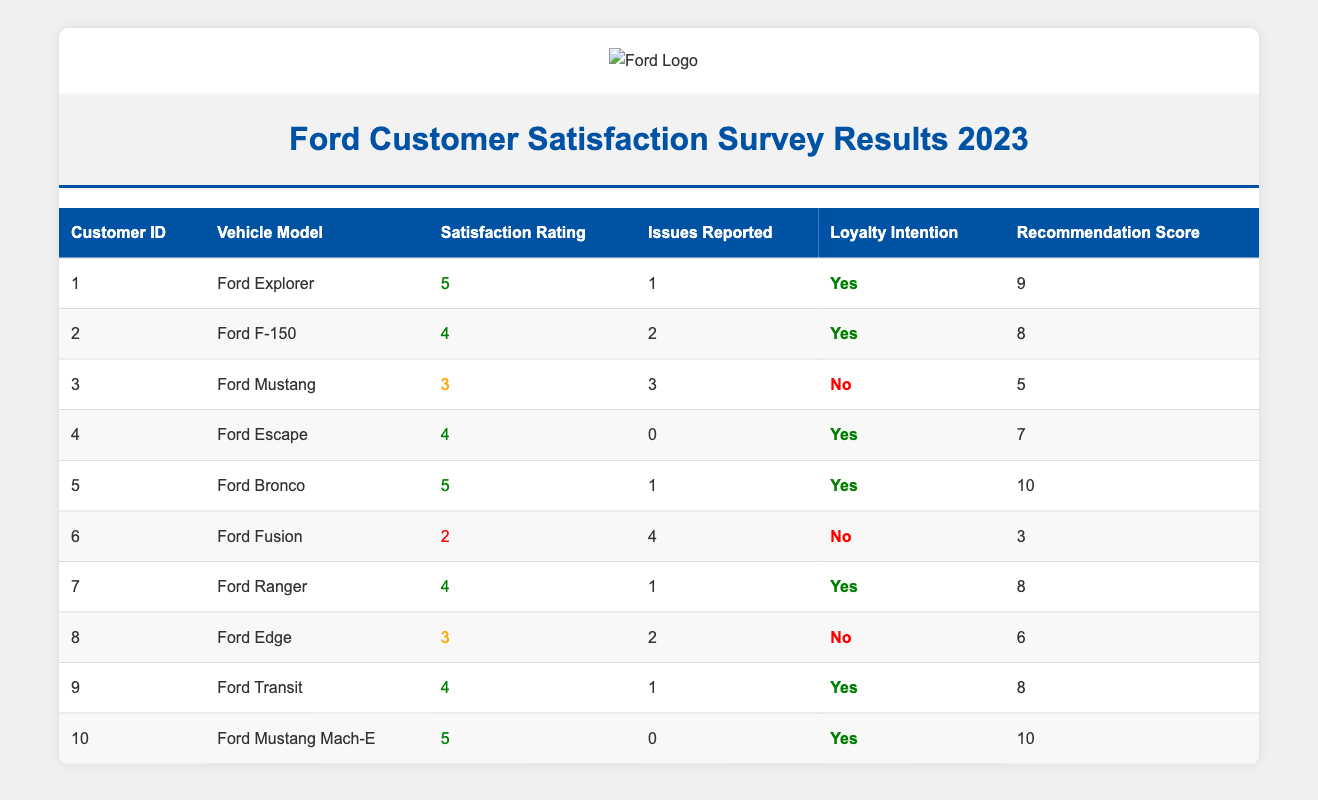What is the satisfaction rating of the Ford F-150? The satisfaction rating for the Ford F-150 is found in the table under the "Satisfaction Rating" column for the specific row corresponding to the Ford F-150. Checking this row, the satisfaction rating is 4.
Answer: 4 How many issues were reported for the Ford Fusion? The "Issues Reported" for the Ford Fusion can be found in the table by locating the specific row for the Ford Fusion. The value in the "Issues Reported" column for this vehicle is 4.
Answer: 4 Which vehicle model has the highest recommendation score? To find the vehicle model with the highest recommendation score, I must compare all the values in the "Recommendation Score" column. The maximum value is 10, which corresponds to both the Ford Bronco and the Ford Mustang Mach-E.
Answer: Ford Bronco and Ford Mustang Mach-E How many customers reported an intention to remain loyal to Ford? The loyalty intention can be identified by filtering the "Loyalty Intention" column for customers who answered "Yes." Counting these entries, I find that there are 7 customers (with customer IDs 1, 2, 4, 5, 7, 9, and 10) indicating loyalty.
Answer: 7 What is the average satisfaction rating for all Ford vehicles listed? To calculate the average satisfaction rating, I need to sum all the satisfaction ratings from the table (5 + 4 + 3 + 4 + 5 + 2 + 4 + 3 + 4 + 5 = 43) and then divide by the number of customers (10). Thus, the average satisfaction rating is 43 / 10 = 4.3.
Answer: 4.3 Is there any vehicle model with a satisfaction rating of 2 or lower? I need to look through the "Satisfaction Rating" column of the table and check for any ratings of 2 or lower. The Ford Fusion has a satisfaction rating of 2. Therefore, the answer is yes.
Answer: Yes What is the difference in recommendation scores between the highest and lowest rated vehicles? First, I find the highest recommendation score (10 from both the Ford Bronco and Ford Mustang Mach-E) and the lowest recommendation score (3 from the Ford Fusion). The difference is 10 - 3 = 7.
Answer: 7 Are there any customers who reported both high satisfaction and high loyalty intention? I need to filter for customers with a satisfaction rating of 4 or 5 and a loyalty intention of "Yes." Checking the table, customers 1, 2, 4, 5, 7, 9, and 10 meet these criteria, confirming there are multiple such customers.
Answer: Yes Which vehicle model has the most reported issues? To determine this, I compare the "Issues Reported" for each vehicle model. The Ford Fusion has the most reported issues, totaling 4.
Answer: Ford Fusion 